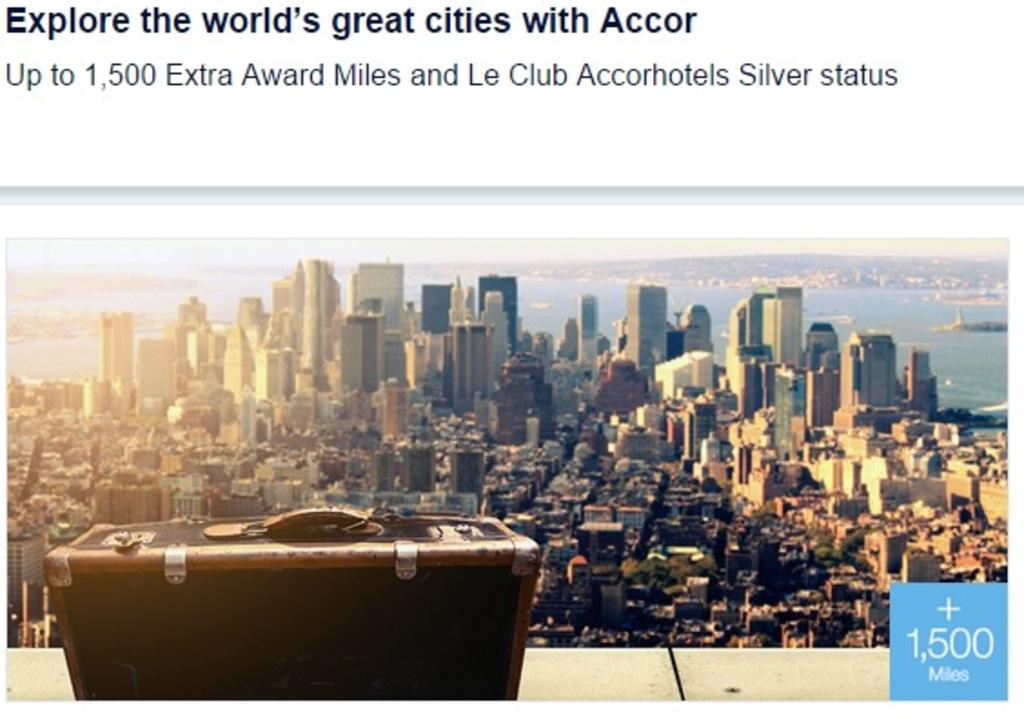What is on the wall in the image? There is a black box on the wall. What can be seen in front of the black box? There are many buildings in front of the black box. What is written at the top of the black box? There is something written at the top of the black box. How many cherries are on the black box in the image? There are no cherries present on the black box in the image. What color is the crayon used to write on the black box? There is no crayon visible in the image, and it is not mentioned that a crayon was used to write on the black box. 